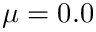Convert formula to latex. <formula><loc_0><loc_0><loc_500><loc_500>\mu = 0 . 0</formula> 